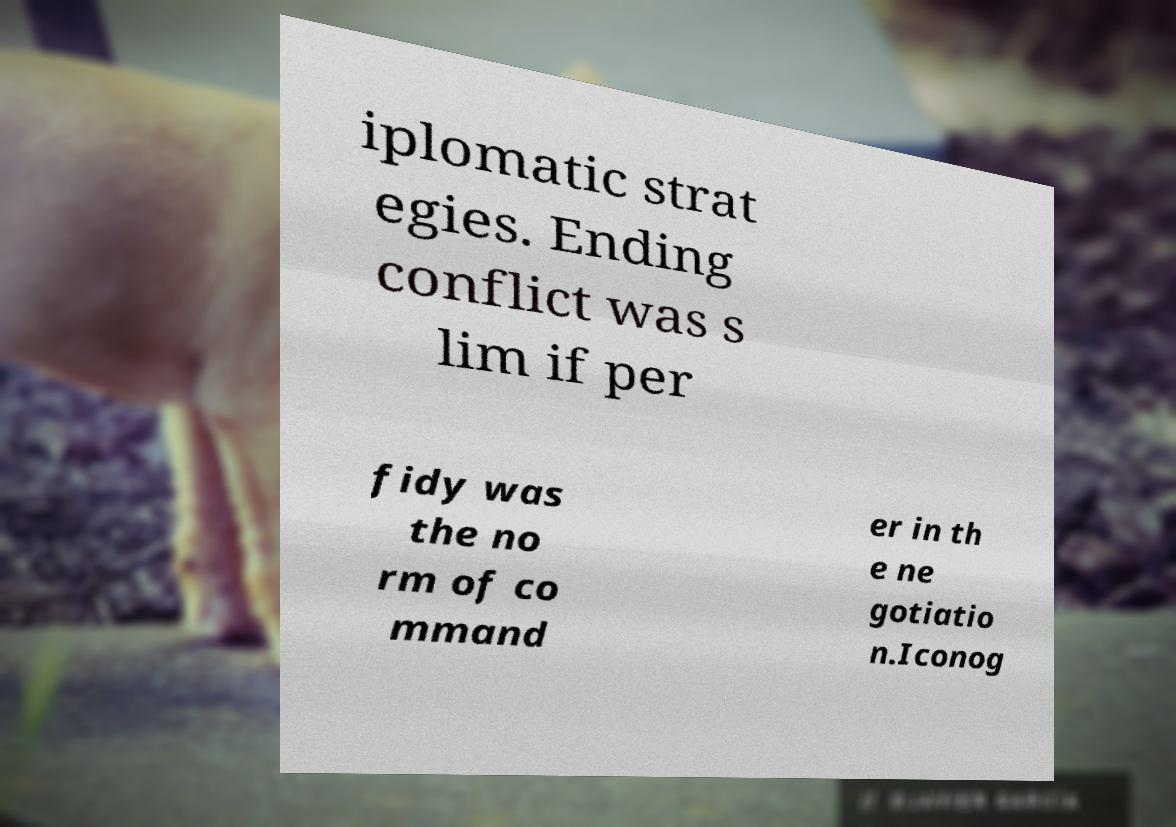There's text embedded in this image that I need extracted. Can you transcribe it verbatim? iplomatic strat egies. Ending conflict was s lim if per fidy was the no rm of co mmand er in th e ne gotiatio n.Iconog 